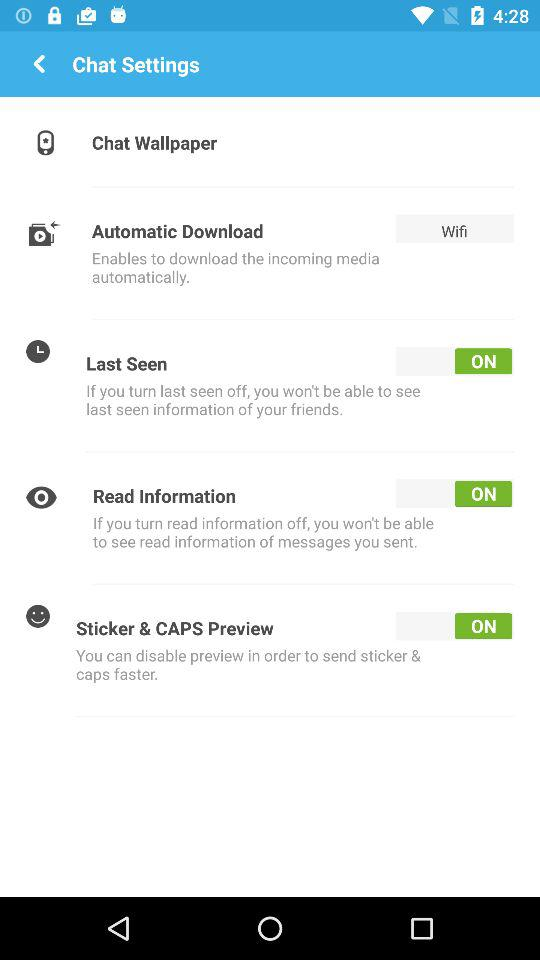How many switches are there?
Answer the question using a single word or phrase. 3 